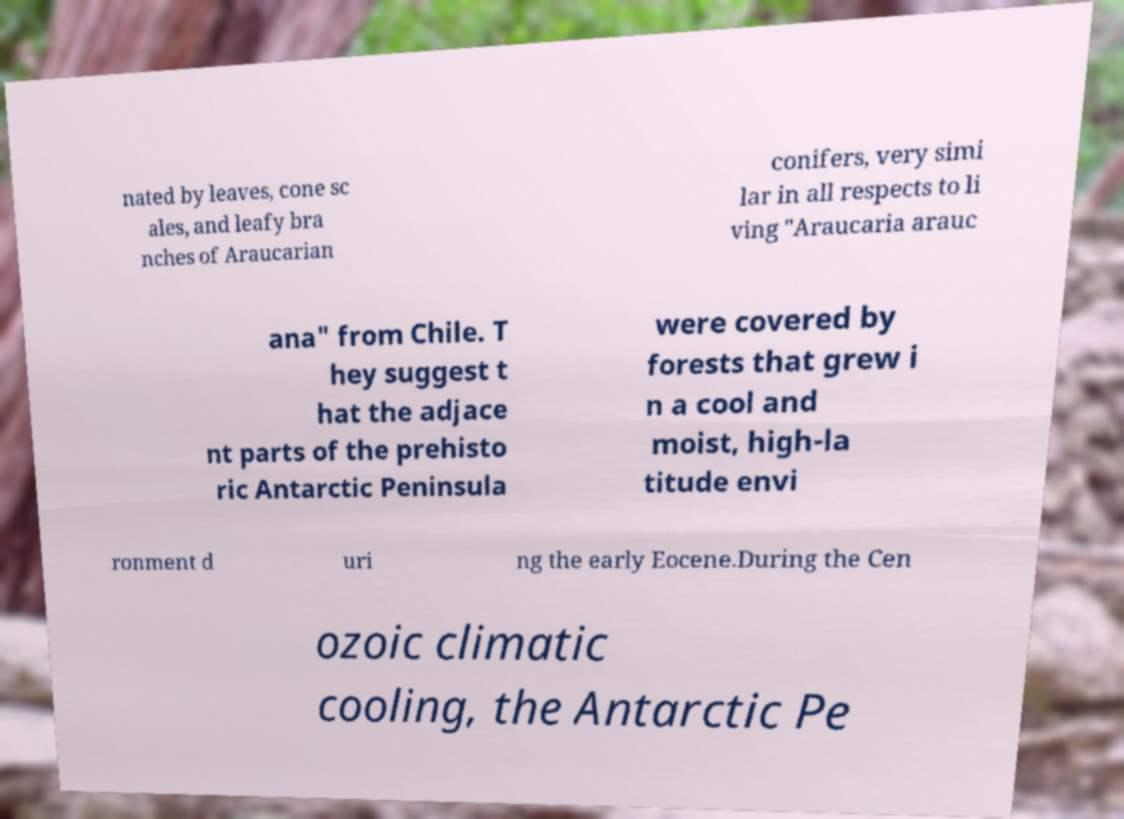Can you read and provide the text displayed in the image?This photo seems to have some interesting text. Can you extract and type it out for me? nated by leaves, cone sc ales, and leafy bra nches of Araucarian conifers, very simi lar in all respects to li ving "Araucaria arauc ana" from Chile. T hey suggest t hat the adjace nt parts of the prehisto ric Antarctic Peninsula were covered by forests that grew i n a cool and moist, high-la titude envi ronment d uri ng the early Eocene.During the Cen ozoic climatic cooling, the Antarctic Pe 